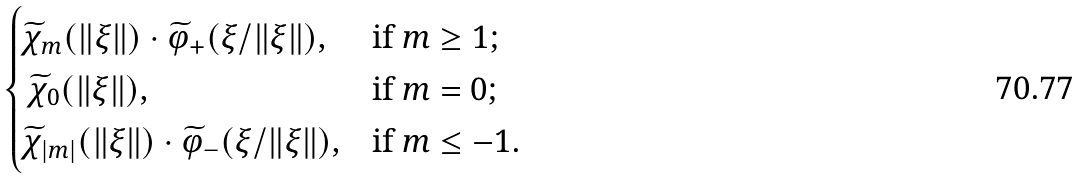<formula> <loc_0><loc_0><loc_500><loc_500>\begin{cases} \widetilde { \chi } _ { m } ( \| \xi \| ) \cdot \widetilde { \varphi } _ { + } ( \xi / \| \xi \| ) , & \text {if $m\geq 1$;} \\ \, \widetilde { \chi } _ { 0 } ( \| \xi \| ) , & \text {if $m=0$;} \\ \widetilde { \chi } _ { | m | } ( \| \xi \| ) \cdot \widetilde { \varphi } _ { - } ( \xi / \| \xi \| ) , & \text {if $m\leq -1$.} \end{cases}</formula> 